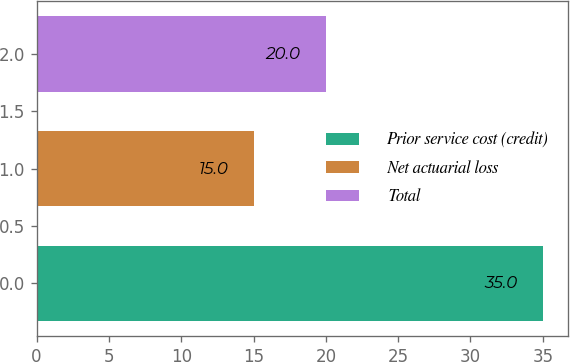Convert chart. <chart><loc_0><loc_0><loc_500><loc_500><bar_chart><fcel>Prior service cost (credit)<fcel>Net actuarial loss<fcel>Total<nl><fcel>35<fcel>15<fcel>20<nl></chart> 